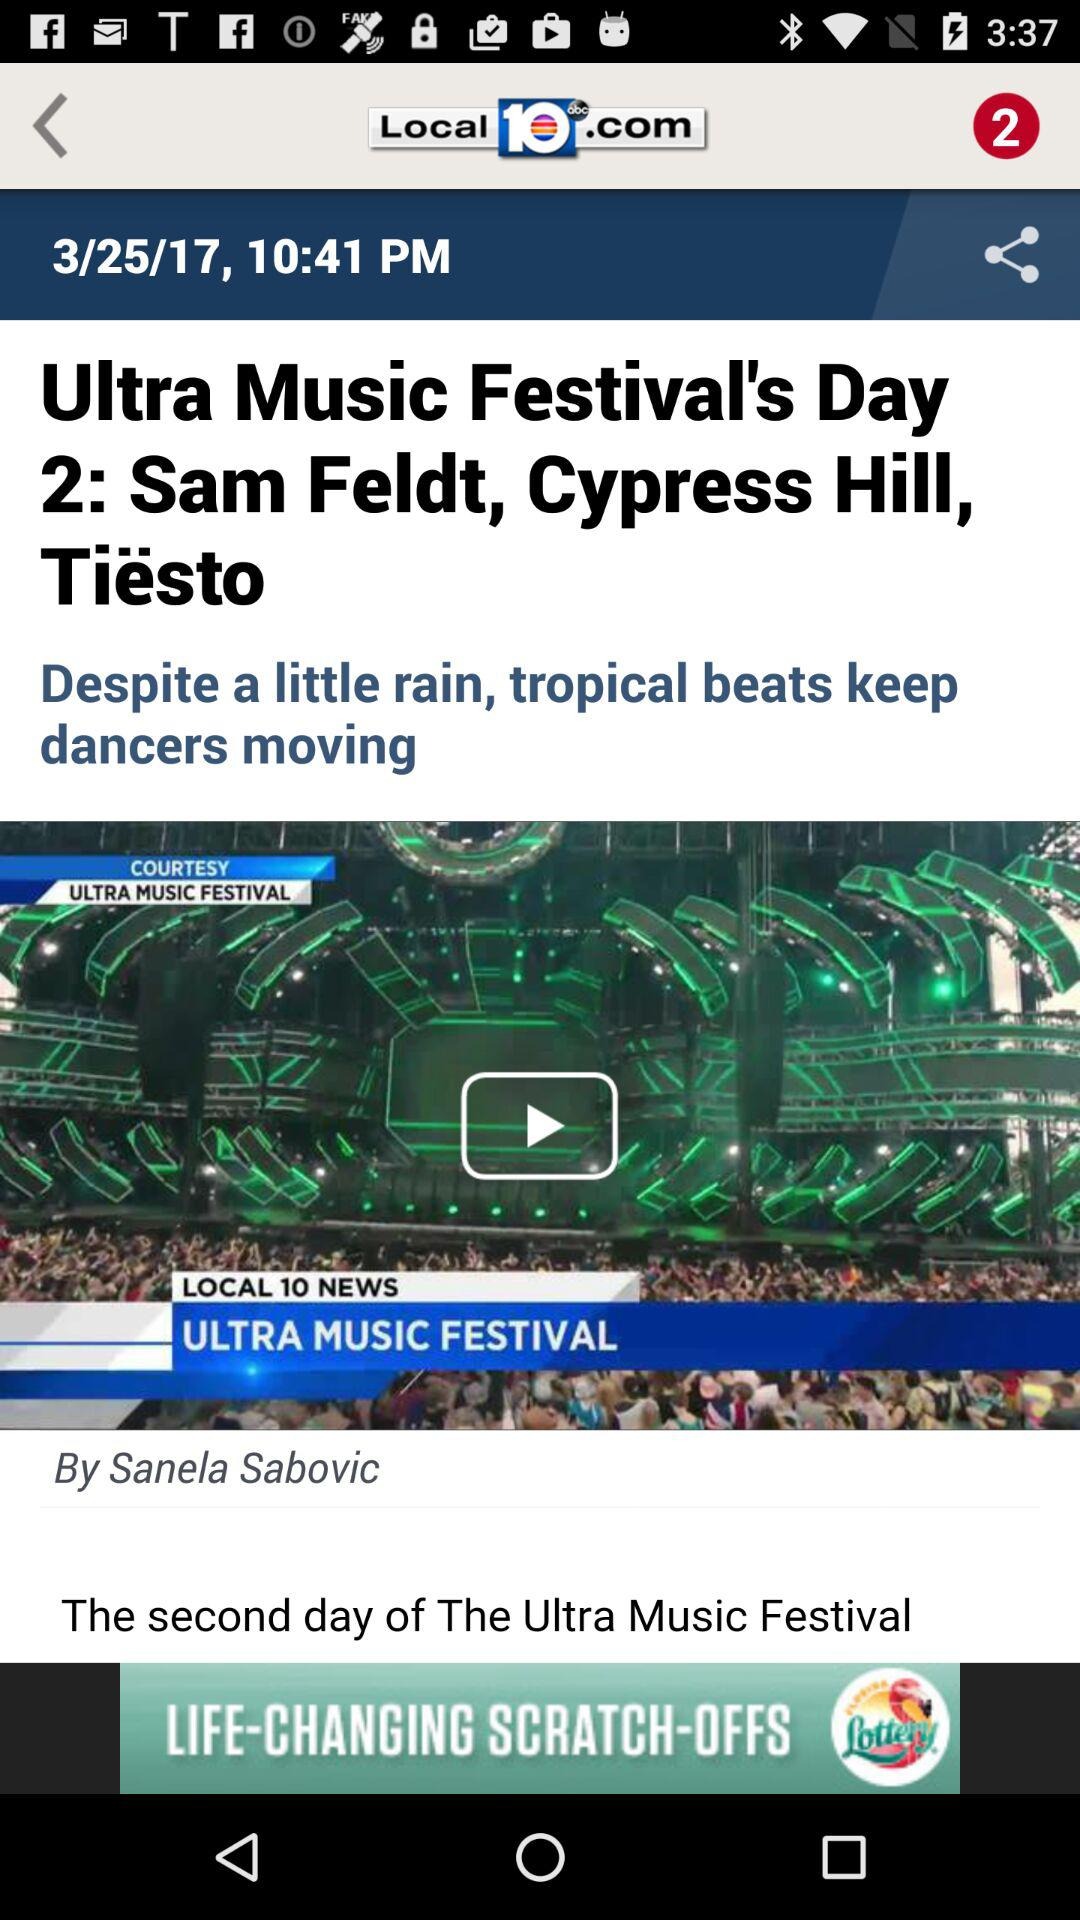What is the author's name? The author's name is Sanela Sabovic. 